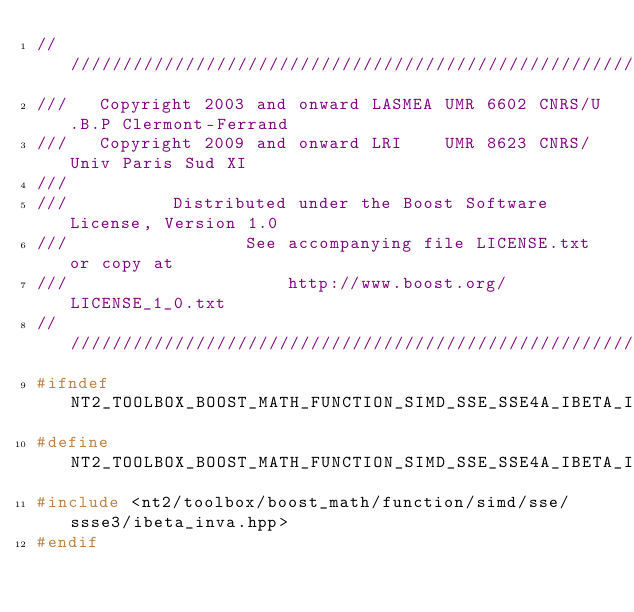Convert code to text. <code><loc_0><loc_0><loc_500><loc_500><_C++_>//////////////////////////////////////////////////////////////////////////////
///   Copyright 2003 and onward LASMEA UMR 6602 CNRS/U.B.P Clermont-Ferrand
///   Copyright 2009 and onward LRI    UMR 8623 CNRS/Univ Paris Sud XI
///
///          Distributed under the Boost Software License, Version 1.0
///                 See accompanying file LICENSE.txt or copy at
///                     http://www.boost.org/LICENSE_1_0.txt
//////////////////////////////////////////////////////////////////////////////
#ifndef NT2_TOOLBOX_BOOST_MATH_FUNCTION_SIMD_SSE_SSE4A_IBETA_INVA_HPP_INCLUDED
#define NT2_TOOLBOX_BOOST_MATH_FUNCTION_SIMD_SSE_SSE4A_IBETA_INVA_HPP_INCLUDED
#include <nt2/toolbox/boost_math/function/simd/sse/ssse3/ibeta_inva.hpp>
#endif
</code> 